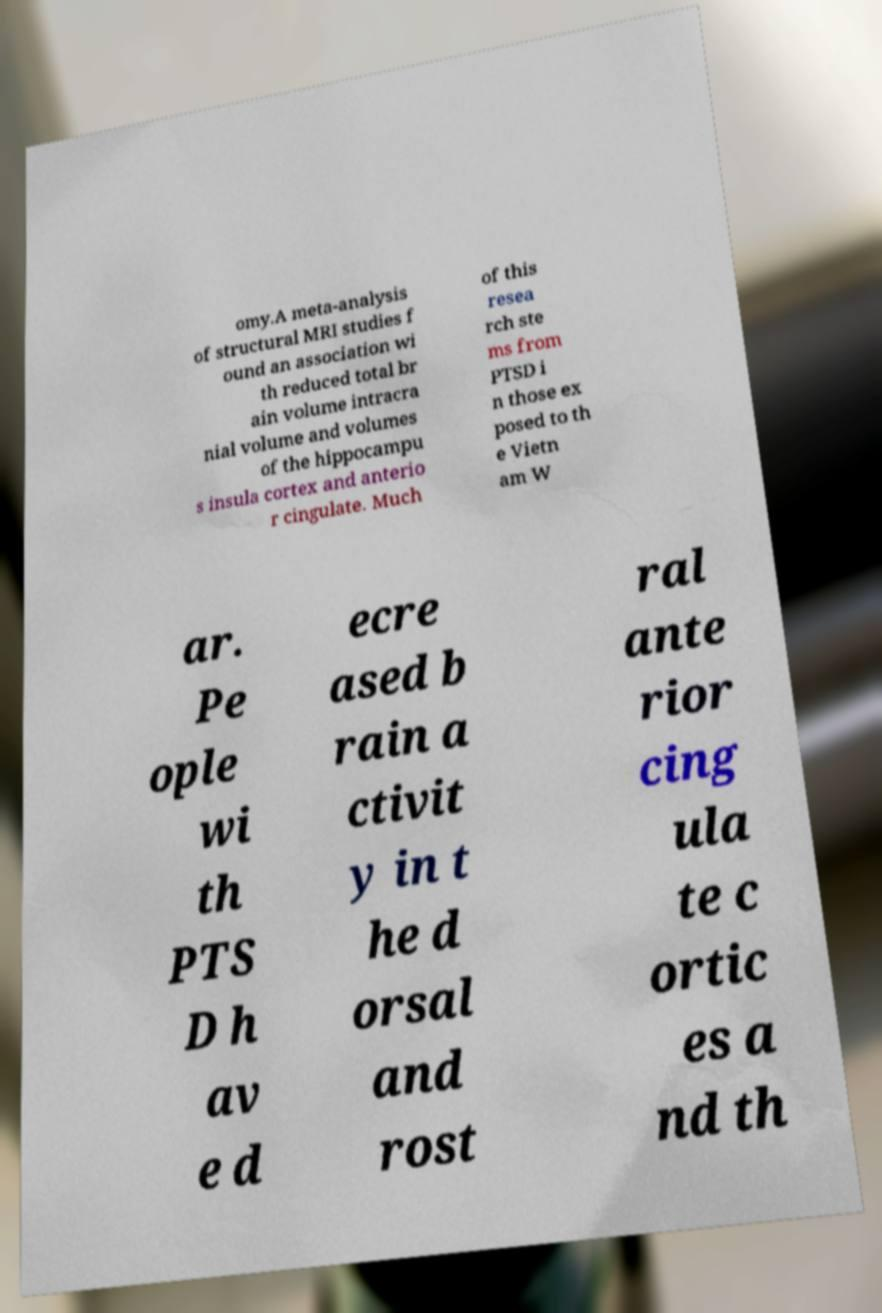I need the written content from this picture converted into text. Can you do that? omy.A meta-analysis of structural MRI studies f ound an association wi th reduced total br ain volume intracra nial volume and volumes of the hippocampu s insula cortex and anterio r cingulate. Much of this resea rch ste ms from PTSD i n those ex posed to th e Vietn am W ar. Pe ople wi th PTS D h av e d ecre ased b rain a ctivit y in t he d orsal and rost ral ante rior cing ula te c ortic es a nd th 